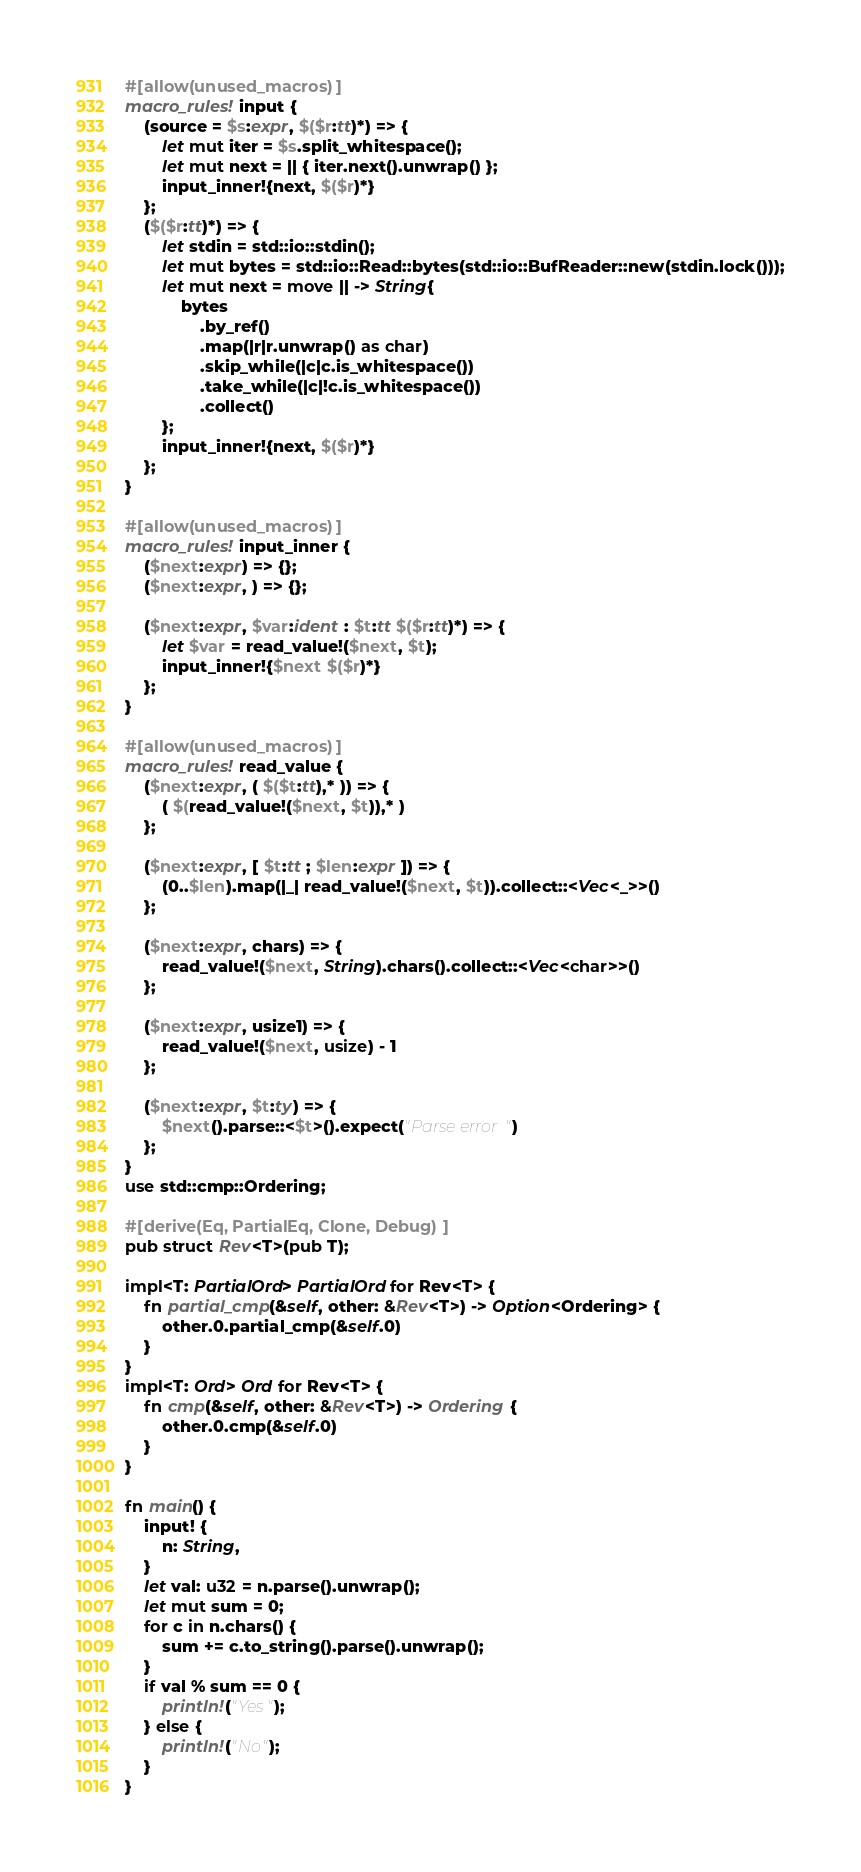<code> <loc_0><loc_0><loc_500><loc_500><_Rust_>#[allow(unused_macros)]
macro_rules! input {
    (source = $s:expr, $($r:tt)*) => {
        let mut iter = $s.split_whitespace();
        let mut next = || { iter.next().unwrap() };
        input_inner!{next, $($r)*}
    };
    ($($r:tt)*) => {
        let stdin = std::io::stdin();
        let mut bytes = std::io::Read::bytes(std::io::BufReader::new(stdin.lock()));
        let mut next = move || -> String{
            bytes
                .by_ref()
                .map(|r|r.unwrap() as char)
                .skip_while(|c|c.is_whitespace())
                .take_while(|c|!c.is_whitespace())
                .collect()
        };
        input_inner!{next, $($r)*}
    };
}

#[allow(unused_macros)]
macro_rules! input_inner {
    ($next:expr) => {};
    ($next:expr, ) => {};

    ($next:expr, $var:ident : $t:tt $($r:tt)*) => {
        let $var = read_value!($next, $t);
        input_inner!{$next $($r)*}
    };
}

#[allow(unused_macros)]
macro_rules! read_value {
    ($next:expr, ( $($t:tt),* )) => {
        ( $(read_value!($next, $t)),* )
    };

    ($next:expr, [ $t:tt ; $len:expr ]) => {
        (0..$len).map(|_| read_value!($next, $t)).collect::<Vec<_>>()
    };

    ($next:expr, chars) => {
        read_value!($next, String).chars().collect::<Vec<char>>()
    };

    ($next:expr, usize1) => {
        read_value!($next, usize) - 1
    };

    ($next:expr, $t:ty) => {
        $next().parse::<$t>().expect("Parse error")
    };
}
use std::cmp::Ordering;

#[derive(Eq, PartialEq, Clone, Debug)]
pub struct Rev<T>(pub T);

impl<T: PartialOrd> PartialOrd for Rev<T> {
    fn partial_cmp(&self, other: &Rev<T>) -> Option<Ordering> {
        other.0.partial_cmp(&self.0)
    }
}
impl<T: Ord> Ord for Rev<T> {
    fn cmp(&self, other: &Rev<T>) -> Ordering {
        other.0.cmp(&self.0)
    }
}

fn main() {
    input! {
        n: String,
    }
    let val: u32 = n.parse().unwrap();
    let mut sum = 0;
    for c in n.chars() {
        sum += c.to_string().parse().unwrap();
    }
    if val % sum == 0 {
        println!("Yes");
    } else {
        println!("No");
    }
}
</code> 